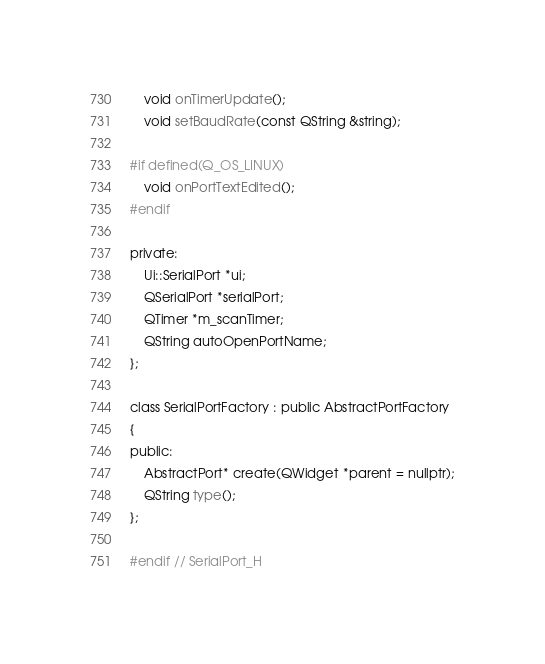<code> <loc_0><loc_0><loc_500><loc_500><_C_>    void onTimerUpdate();
    void setBaudRate(const QString &string);

#if defined(Q_OS_LINUX)
    void onPortTextEdited();
#endif

private:
    Ui::SerialPort *ui;
    QSerialPort *serialPort;
    QTimer *m_scanTimer;
    QString autoOpenPortName;
};

class SerialPortFactory : public AbstractPortFactory
{
public:
    AbstractPort* create(QWidget *parent = nullptr);
    QString type();
};

#endif // SerialPort_H
</code> 